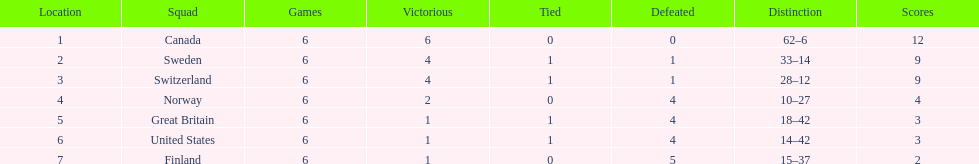What is the total number of teams to have 4 total wins? 2. Can you parse all the data within this table? {'header': ['Location', 'Squad', 'Games', 'Victorious', 'Tied', 'Defeated', 'Distinction', 'Scores'], 'rows': [['1', 'Canada', '6', '6', '0', '0', '62–6', '12'], ['2', 'Sweden', '6', '4', '1', '1', '33–14', '9'], ['3', 'Switzerland', '6', '4', '1', '1', '28–12', '9'], ['4', 'Norway', '6', '2', '0', '4', '10–27', '4'], ['5', 'Great Britain', '6', '1', '1', '4', '18–42', '3'], ['6', 'United States', '6', '1', '1', '4', '14–42', '3'], ['7', 'Finland', '6', '1', '0', '5', '15–37', '2']]} 